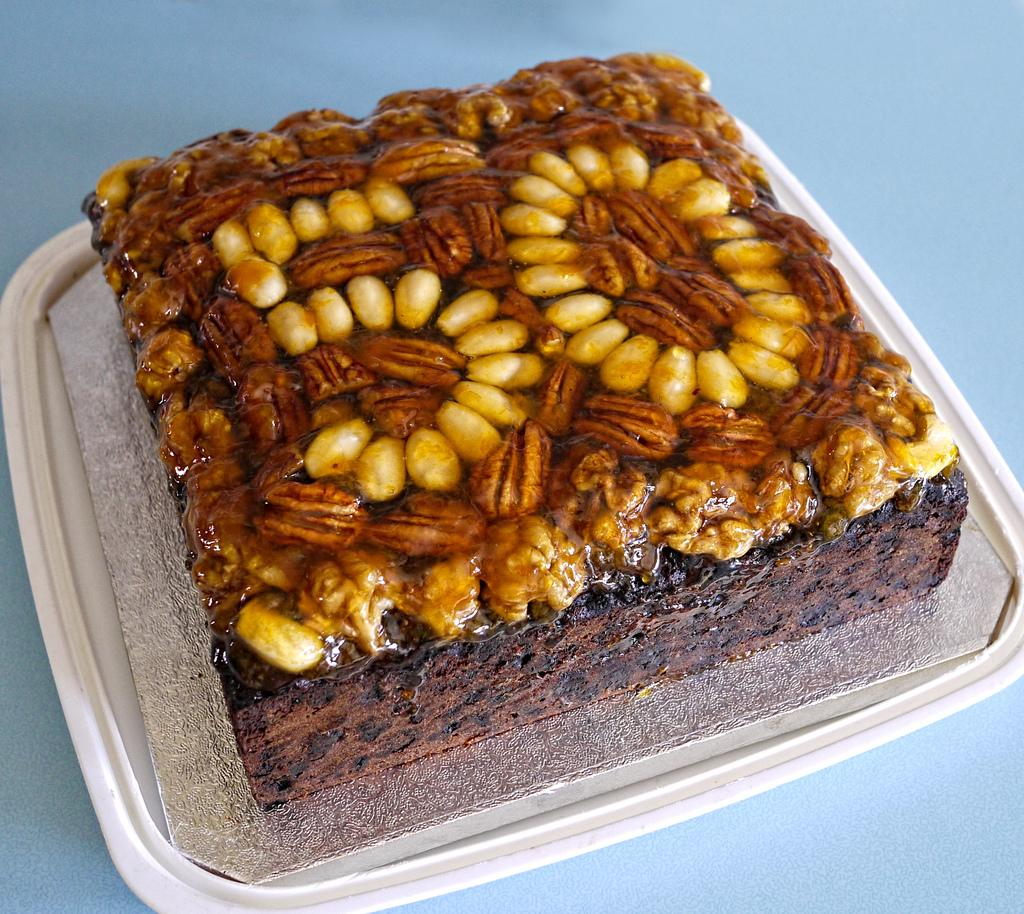What is the main subject of the image? There is a cake in the image. How is the cake being presented or displayed? The cake is on a tray. What color or type of surface is visible in the image? There is a blue surface in the image. Can you tell me how many people are talking on the street in the image? There is no mention of people talking on the street in the image; it only features a cake on a tray and a blue surface. 